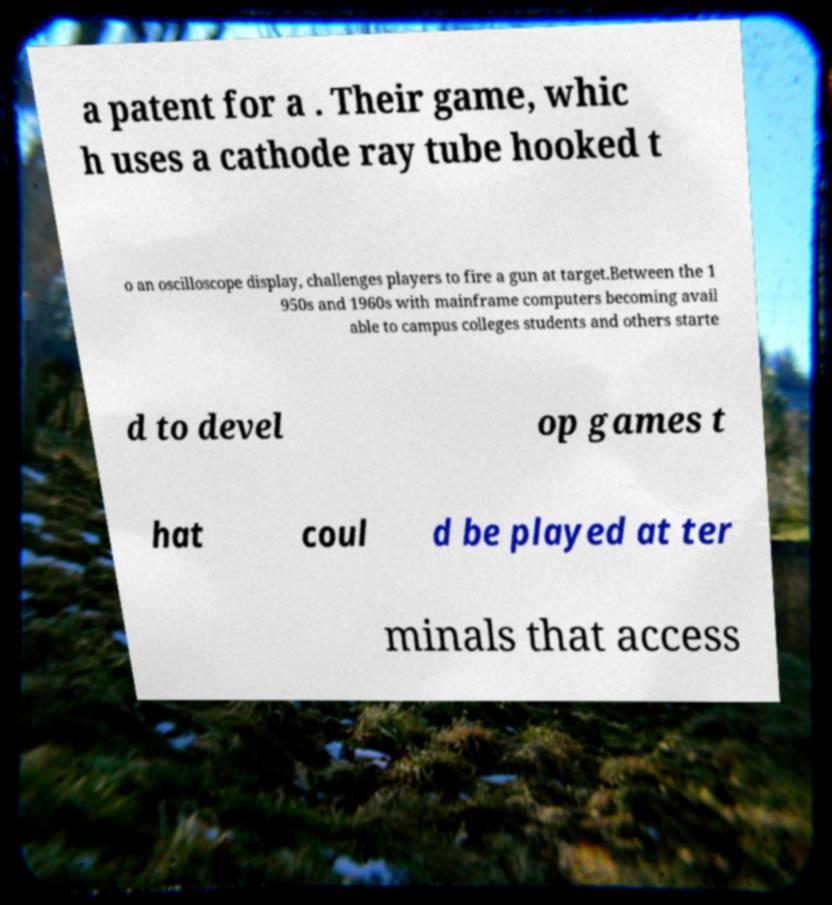Could you assist in decoding the text presented in this image and type it out clearly? a patent for a . Their game, whic h uses a cathode ray tube hooked t o an oscilloscope display, challenges players to fire a gun at target.Between the 1 950s and 1960s with mainframe computers becoming avail able to campus colleges students and others starte d to devel op games t hat coul d be played at ter minals that access 